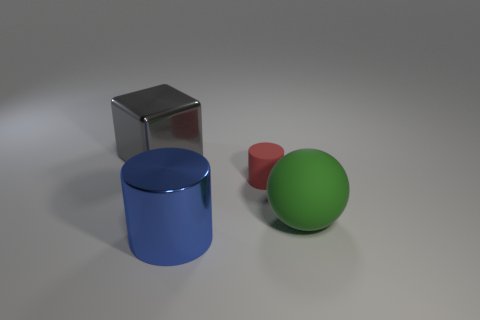Add 4 tiny rubber objects. How many objects exist? 8 Subtract all cubes. How many objects are left? 3 Subtract all blue cylinders. How many cylinders are left? 1 Subtract 0 brown cubes. How many objects are left? 4 Subtract 1 balls. How many balls are left? 0 Subtract all gray balls. Subtract all blue cylinders. How many balls are left? 1 Subtract all gray spheres. How many red cylinders are left? 1 Subtract all blue cylinders. Subtract all big blocks. How many objects are left? 2 Add 4 big metal cylinders. How many big metal cylinders are left? 5 Add 2 tiny cylinders. How many tiny cylinders exist? 3 